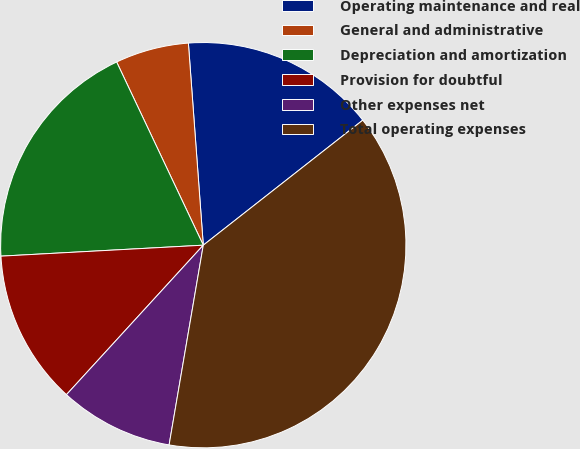Convert chart. <chart><loc_0><loc_0><loc_500><loc_500><pie_chart><fcel>Operating maintenance and real<fcel>General and administrative<fcel>Depreciation and amortization<fcel>Provision for doubtful<fcel>Other expenses net<fcel>Total operating expenses<nl><fcel>15.59%<fcel>5.86%<fcel>18.83%<fcel>12.34%<fcel>9.1%<fcel>38.28%<nl></chart> 